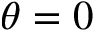Convert formula to latex. <formula><loc_0><loc_0><loc_500><loc_500>\theta = 0</formula> 